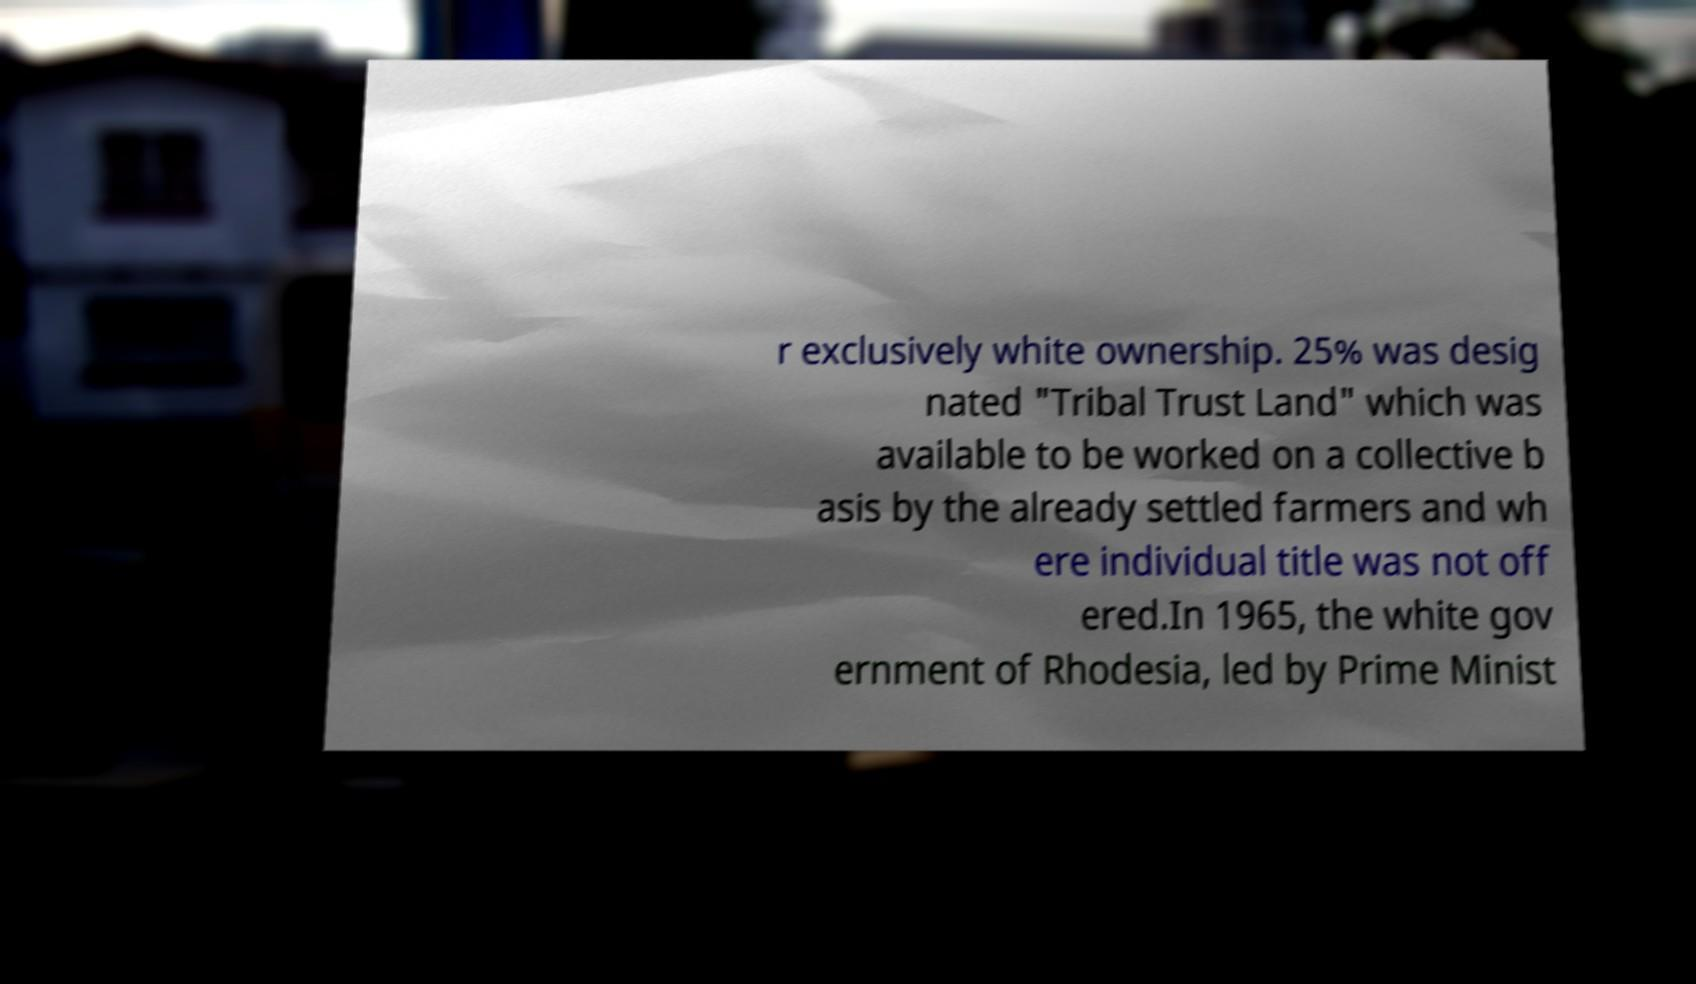Please identify and transcribe the text found in this image. r exclusively white ownership. 25% was desig nated "Tribal Trust Land" which was available to be worked on a collective b asis by the already settled farmers and wh ere individual title was not off ered.In 1965, the white gov ernment of Rhodesia, led by Prime Minist 